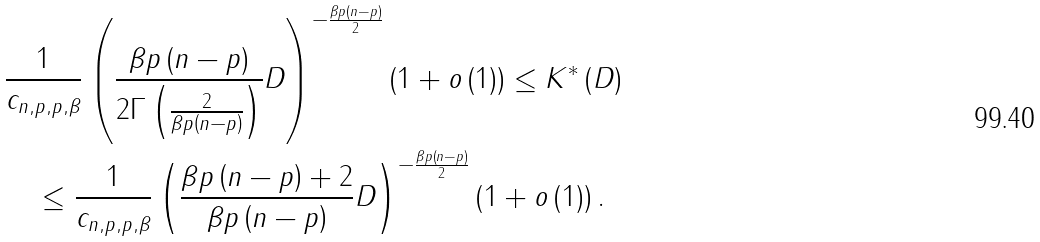Convert formula to latex. <formula><loc_0><loc_0><loc_500><loc_500>& \frac { 1 } { c _ { n , p , p , \beta } } \left ( \frac { \beta p \left ( n - p \right ) } { 2 \Gamma \left ( \frac { 2 } { \beta p \left ( n - p \right ) } \right ) } D \right ) ^ { - \frac { \beta p \left ( n - p \right ) } { 2 } } \left ( 1 + o \left ( 1 \right ) \right ) \leq K ^ { * } \left ( D \right ) \\ & \quad \leq \frac { 1 } { c _ { n , p , p , \beta } } \left ( \frac { \beta p \left ( n - p \right ) + 2 } { \beta p \left ( n - p \right ) } D \right ) ^ { - \frac { \beta p \left ( n - p \right ) } { 2 } } \left ( 1 + o \left ( 1 \right ) \right ) .</formula> 